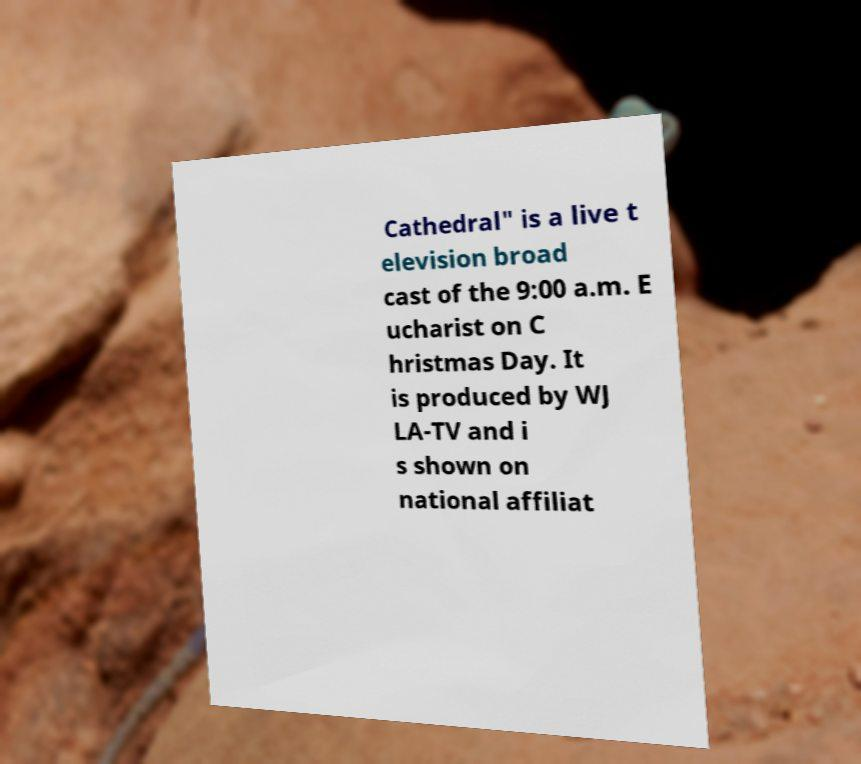Could you assist in decoding the text presented in this image and type it out clearly? Cathedral" is a live t elevision broad cast of the 9:00 a.m. E ucharist on C hristmas Day. It is produced by WJ LA-TV and i s shown on national affiliat 